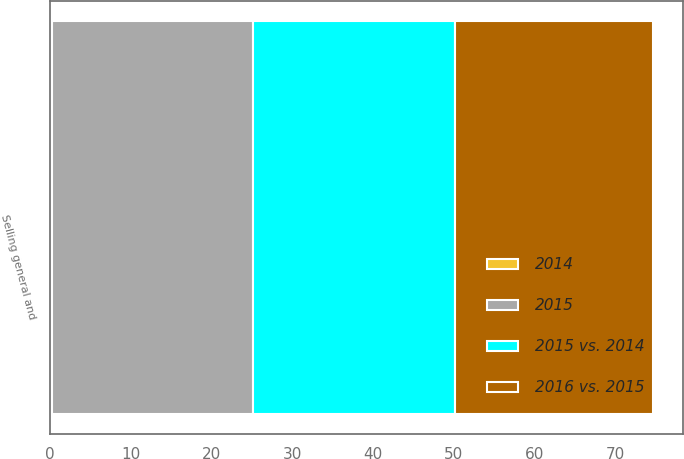Convert chart. <chart><loc_0><loc_0><loc_500><loc_500><stacked_bar_chart><ecel><fcel>Selling general and<nl><fcel>2015<fcel>24.8<nl><fcel>2016 vs. 2015<fcel>24.5<nl><fcel>2015 vs. 2014<fcel>25<nl><fcel>2014<fcel>0.3<nl></chart> 